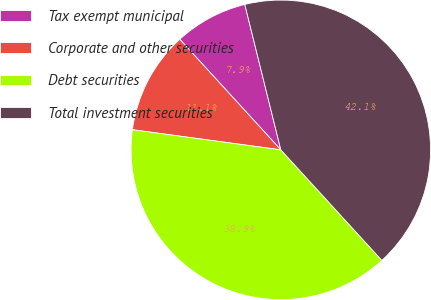Convert chart to OTSL. <chart><loc_0><loc_0><loc_500><loc_500><pie_chart><fcel>Tax exempt municipal<fcel>Corporate and other securities<fcel>Debt securities<fcel>Total investment securities<nl><fcel>7.92%<fcel>11.07%<fcel>38.93%<fcel>42.08%<nl></chart> 